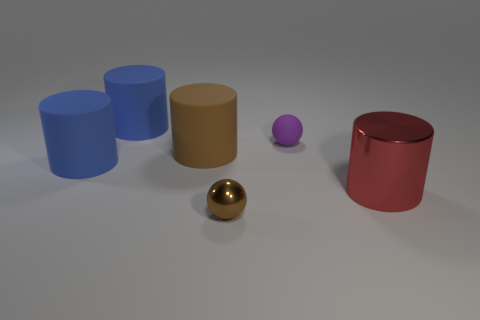Is there a metal sphere of the same color as the matte sphere?
Offer a very short reply. No. There is a ball behind the red cylinder; is it the same size as the small brown metallic ball?
Offer a terse response. Yes. What color is the small rubber sphere?
Make the answer very short. Purple. What color is the big cylinder on the right side of the tiny thing in front of the metallic cylinder?
Provide a short and direct response. Red. Are there any small purple cylinders that have the same material as the small purple object?
Offer a very short reply. No. There is a object that is in front of the big red cylinder that is to the right of the purple ball; what is it made of?
Provide a short and direct response. Metal. How many other things are the same shape as the brown rubber thing?
Offer a terse response. 3. What is the shape of the red metallic object?
Your answer should be very brief. Cylinder. Is the number of large blue rubber cylinders less than the number of small metal spheres?
Your answer should be very brief. No. Are there any other things that have the same size as the brown cylinder?
Your answer should be very brief. Yes. 